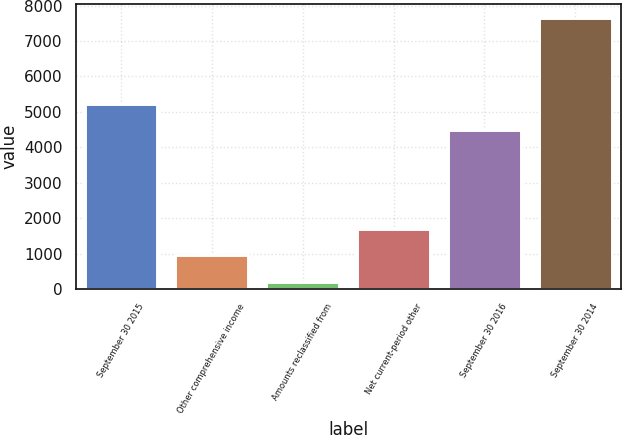Convert chart to OTSL. <chart><loc_0><loc_0><loc_500><loc_500><bar_chart><fcel>September 30 2015<fcel>Other comprehensive income<fcel>Amounts reclassified from<fcel>Net current-period other<fcel>September 30 2016<fcel>September 30 2014<nl><fcel>5230<fcel>948<fcel>202<fcel>1694<fcel>4484<fcel>7662<nl></chart> 